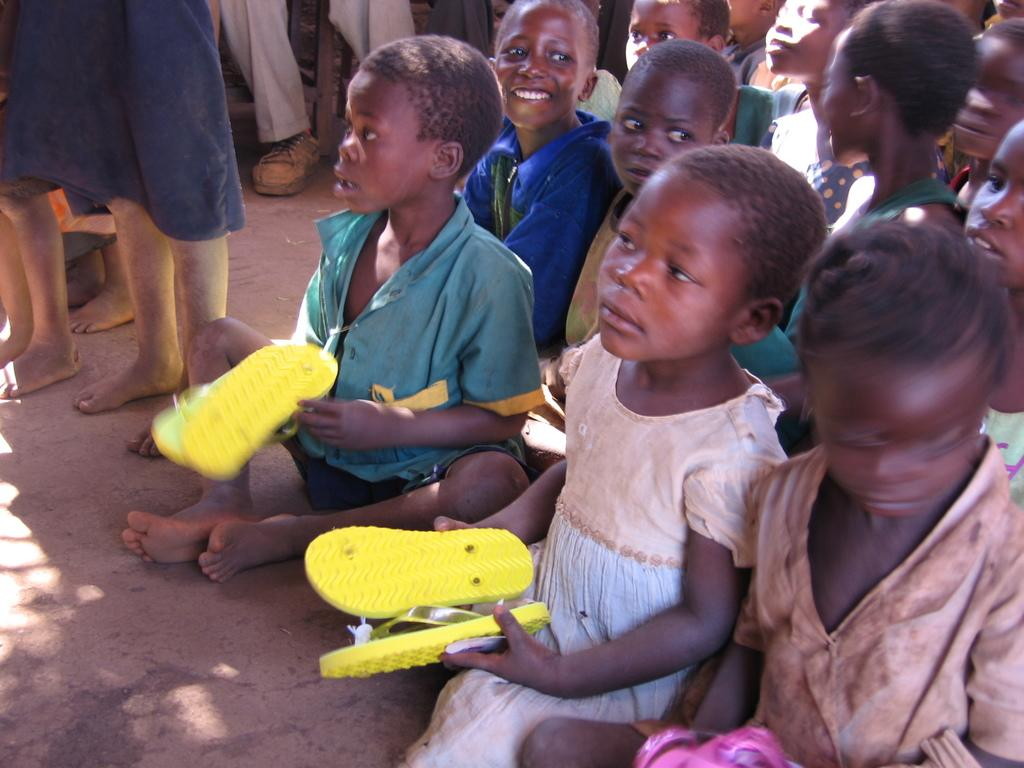What activity is the person in the image engaged in? The person is cooking in a kitchen. How does the person in the image increase the temperature of the oven? The image does not show the person adjusting the oven temperature, so it cannot be determined from the picture. 